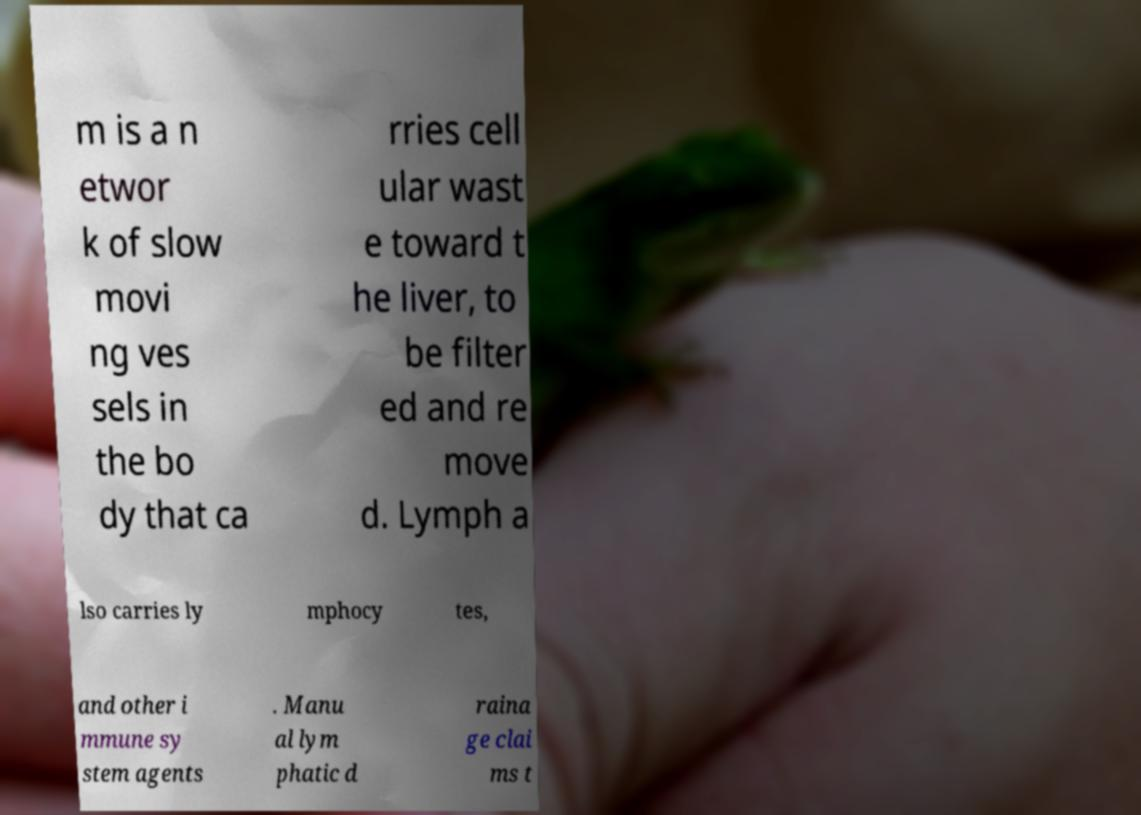Can you read and provide the text displayed in the image?This photo seems to have some interesting text. Can you extract and type it out for me? m is a n etwor k of slow movi ng ves sels in the bo dy that ca rries cell ular wast e toward t he liver, to be filter ed and re move d. Lymph a lso carries ly mphocy tes, and other i mmune sy stem agents . Manu al lym phatic d raina ge clai ms t 